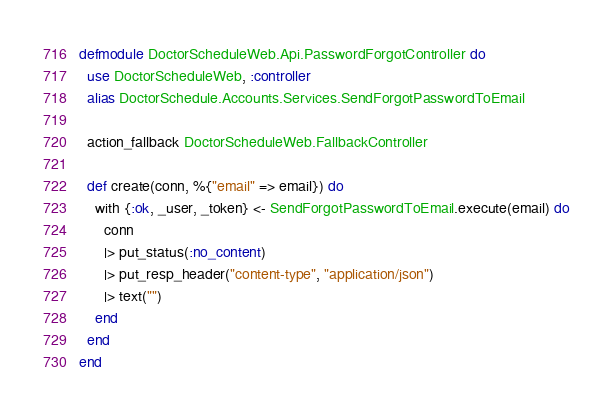Convert code to text. <code><loc_0><loc_0><loc_500><loc_500><_Elixir_>defmodule DoctorScheduleWeb.Api.PasswordForgotController do
  use DoctorScheduleWeb, :controller
  alias DoctorSchedule.Accounts.Services.SendForgotPasswordToEmail

  action_fallback DoctorScheduleWeb.FallbackController

  def create(conn, %{"email" => email}) do
    with {:ok, _user, _token} <- SendForgotPasswordToEmail.execute(email) do
      conn
      |> put_status(:no_content)
      |> put_resp_header("content-type", "application/json")
      |> text("")
    end
  end
end
</code> 